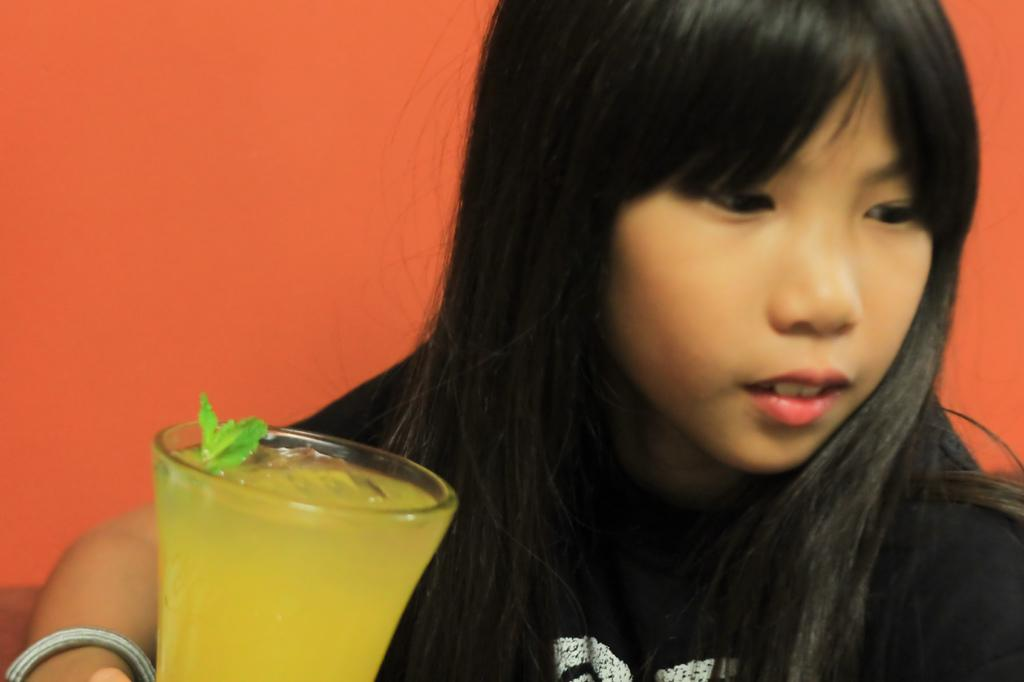Who is the main subject in the image? There is a girl in the image. What object can be seen near the girl? There is a glass with liquid in the image. What color is the background of the image? The background of the image is orange in color. What type of ear is visible on the girl in the image? There is no ear visible on the girl in the image. Is there a lawyer present in the image? There is no lawyer present in the image. 